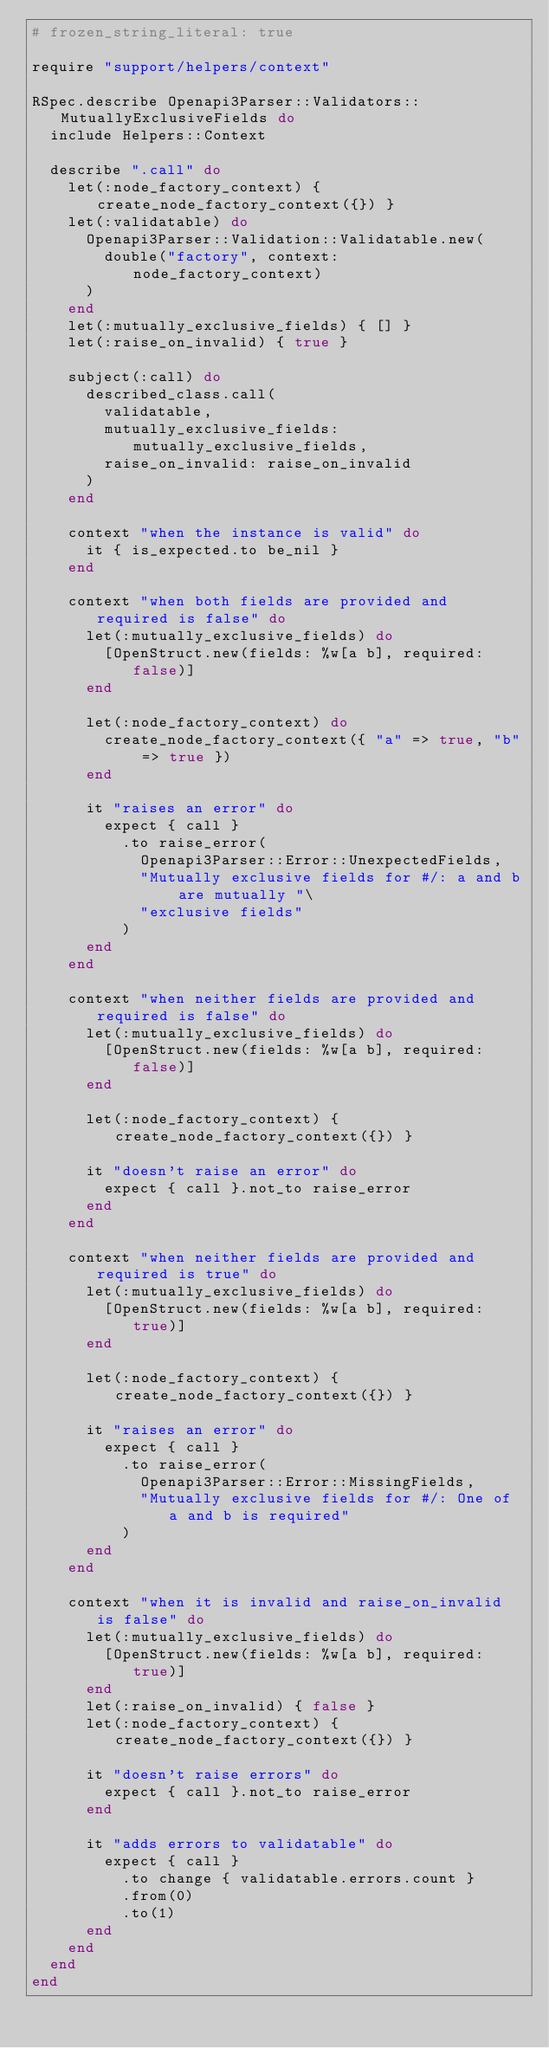<code> <loc_0><loc_0><loc_500><loc_500><_Ruby_># frozen_string_literal: true

require "support/helpers/context"

RSpec.describe Openapi3Parser::Validators::MutuallyExclusiveFields do
  include Helpers::Context

  describe ".call" do
    let(:node_factory_context) { create_node_factory_context({}) }
    let(:validatable) do
      Openapi3Parser::Validation::Validatable.new(
        double("factory", context: node_factory_context)
      )
    end
    let(:mutually_exclusive_fields) { [] }
    let(:raise_on_invalid) { true }

    subject(:call) do
      described_class.call(
        validatable,
        mutually_exclusive_fields: mutually_exclusive_fields,
        raise_on_invalid: raise_on_invalid
      )
    end

    context "when the instance is valid" do
      it { is_expected.to be_nil }
    end

    context "when both fields are provided and required is false" do
      let(:mutually_exclusive_fields) do
        [OpenStruct.new(fields: %w[a b], required: false)]
      end

      let(:node_factory_context) do
        create_node_factory_context({ "a" => true, "b" => true })
      end

      it "raises an error" do
        expect { call }
          .to raise_error(
            Openapi3Parser::Error::UnexpectedFields,
            "Mutually exclusive fields for #/: a and b are mutually "\
            "exclusive fields"
          )
      end
    end

    context "when neither fields are provided and required is false" do
      let(:mutually_exclusive_fields) do
        [OpenStruct.new(fields: %w[a b], required: false)]
      end

      let(:node_factory_context) { create_node_factory_context({}) }

      it "doesn't raise an error" do
        expect { call }.not_to raise_error
      end
    end

    context "when neither fields are provided and required is true" do
      let(:mutually_exclusive_fields) do
        [OpenStruct.new(fields: %w[a b], required: true)]
      end

      let(:node_factory_context) { create_node_factory_context({}) }

      it "raises an error" do
        expect { call }
          .to raise_error(
            Openapi3Parser::Error::MissingFields,
            "Mutually exclusive fields for #/: One of a and b is required"
          )
      end
    end

    context "when it is invalid and raise_on_invalid is false" do
      let(:mutually_exclusive_fields) do
        [OpenStruct.new(fields: %w[a b], required: true)]
      end
      let(:raise_on_invalid) { false }
      let(:node_factory_context) { create_node_factory_context({}) }

      it "doesn't raise errors" do
        expect { call }.not_to raise_error
      end

      it "adds errors to validatable" do
        expect { call }
          .to change { validatable.errors.count }
          .from(0)
          .to(1)
      end
    end
  end
end
</code> 